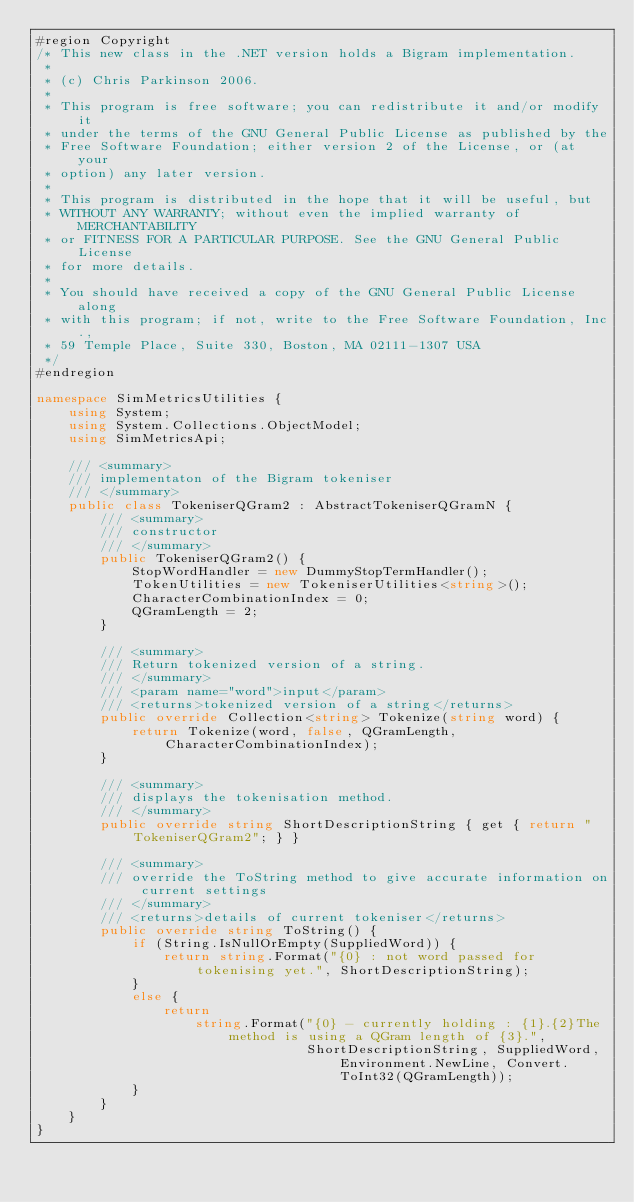<code> <loc_0><loc_0><loc_500><loc_500><_C#_>#region Copyright
/* This new class in the .NET version holds a Bigram implementation.
 * 
 * (c) Chris Parkinson 2006.
 *
 * This program is free software; you can redistribute it and/or modify it
 * under the terms of the GNU General Public License as published by the
 * Free Software Foundation; either version 2 of the License, or (at your
 * option) any later version.
 *
 * This program is distributed in the hope that it will be useful, but
 * WITHOUT ANY WARRANTY; without even the implied warranty of MERCHANTABILITY
 * or FITNESS FOR A PARTICULAR PURPOSE. See the GNU General Public License
 * for more details.
 *
 * You should have received a copy of the GNU General Public License along
 * with this program; if not, write to the Free Software Foundation, Inc.,
 * 59 Temple Place, Suite 330, Boston, MA 02111-1307 USA
 */
#endregion

namespace SimMetricsUtilities {
    using System;
    using System.Collections.ObjectModel;
    using SimMetricsApi;

    /// <summary>
    /// implementaton of the Bigram tokeniser
    /// </summary>
    public class TokeniserQGram2 : AbstractTokeniserQGramN {
        /// <summary>
        /// constructor
        /// </summary>
        public TokeniserQGram2() {
            StopWordHandler = new DummyStopTermHandler();
            TokenUtilities = new TokeniserUtilities<string>();
            CharacterCombinationIndex = 0;
            QGramLength = 2;
        }

        /// <summary>
        /// Return tokenized version of a string.
        /// </summary>
        /// <param name="word">input</param>
        /// <returns>tokenized version of a string</returns>
        public override Collection<string> Tokenize(string word) {
            return Tokenize(word, false, QGramLength, CharacterCombinationIndex);
        }

        /// <summary>
        /// displays the tokenisation method.
        /// </summary>
        public override string ShortDescriptionString { get { return "TokeniserQGram2"; } }

        /// <summary>
        /// override the ToString method to give accurate information on current settings
        /// </summary>
        /// <returns>details of current tokeniser</returns>
        public override string ToString() {
            if (String.IsNullOrEmpty(SuppliedWord)) {
                return string.Format("{0} : not word passed for tokenising yet.", ShortDescriptionString);
            }
            else {
                return
                    string.Format("{0} - currently holding : {1}.{2}The method is using a QGram length of {3}.",
                                  ShortDescriptionString, SuppliedWord, Environment.NewLine, Convert.ToInt32(QGramLength));
            }
        }
    }
}</code> 